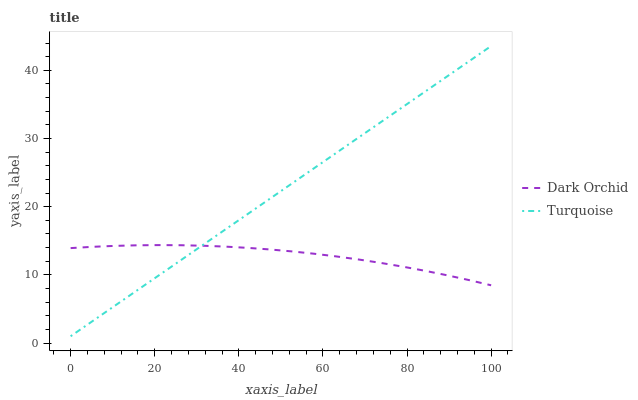Does Dark Orchid have the minimum area under the curve?
Answer yes or no. Yes. Does Turquoise have the maximum area under the curve?
Answer yes or no. Yes. Does Dark Orchid have the maximum area under the curve?
Answer yes or no. No. Is Turquoise the smoothest?
Answer yes or no. Yes. Is Dark Orchid the roughest?
Answer yes or no. Yes. Is Dark Orchid the smoothest?
Answer yes or no. No. Does Turquoise have the lowest value?
Answer yes or no. Yes. Does Dark Orchid have the lowest value?
Answer yes or no. No. Does Turquoise have the highest value?
Answer yes or no. Yes. Does Dark Orchid have the highest value?
Answer yes or no. No. Does Turquoise intersect Dark Orchid?
Answer yes or no. Yes. Is Turquoise less than Dark Orchid?
Answer yes or no. No. Is Turquoise greater than Dark Orchid?
Answer yes or no. No. 